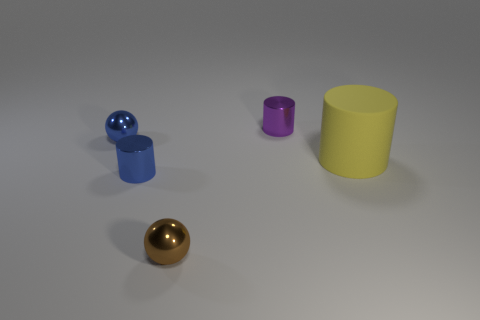Subtract all cylinders. How many objects are left? 2 Subtract 1 spheres. How many spheres are left? 1 Subtract all blue balls. Subtract all cyan cylinders. How many balls are left? 1 Subtract all red blocks. How many gray cylinders are left? 0 Subtract all big yellow objects. Subtract all big cylinders. How many objects are left? 3 Add 3 yellow cylinders. How many yellow cylinders are left? 4 Add 3 metal spheres. How many metal spheres exist? 5 Add 1 blue spheres. How many objects exist? 6 Subtract all purple cylinders. How many cylinders are left? 2 Subtract all metal cylinders. How many cylinders are left? 1 